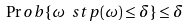Convert formula to latex. <formula><loc_0><loc_0><loc_500><loc_500>\Pr o b \{ \omega \ s t p ( \omega ) \leq \delta \} \leq \delta</formula> 